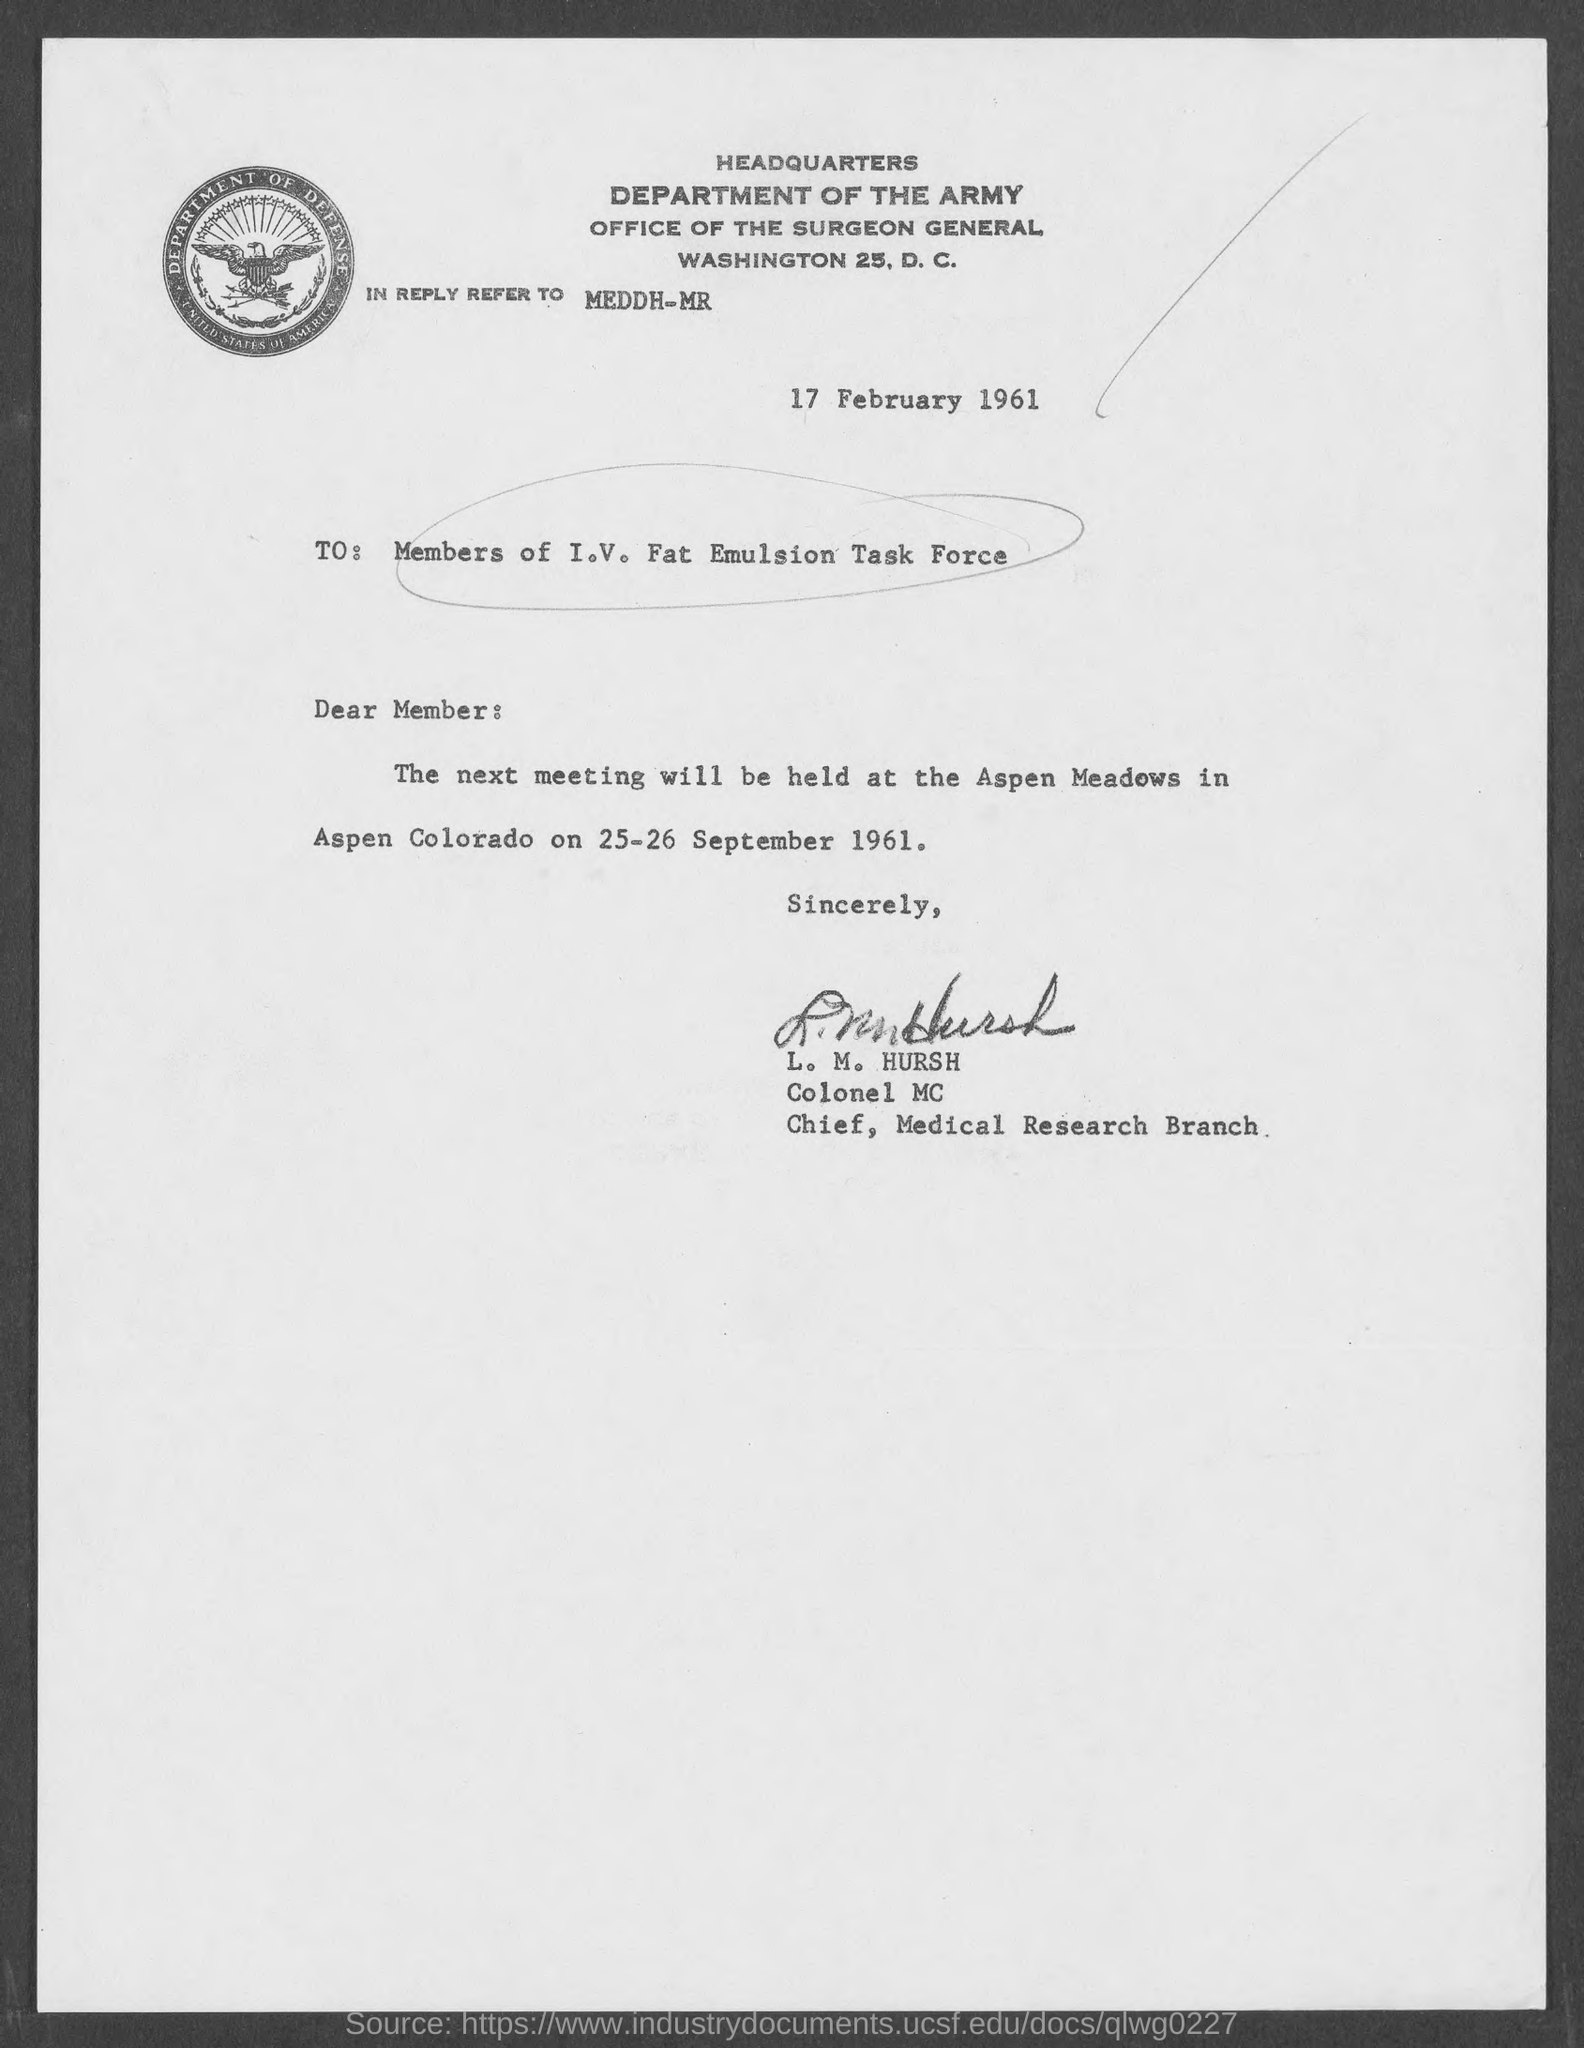What is the date mentioned in the top of the document ?
Make the answer very short. 17 February 1961. Who is the Memorandum Address to ?
Give a very brief answer. Members of I.V. Fat Emulsion Task Force. 